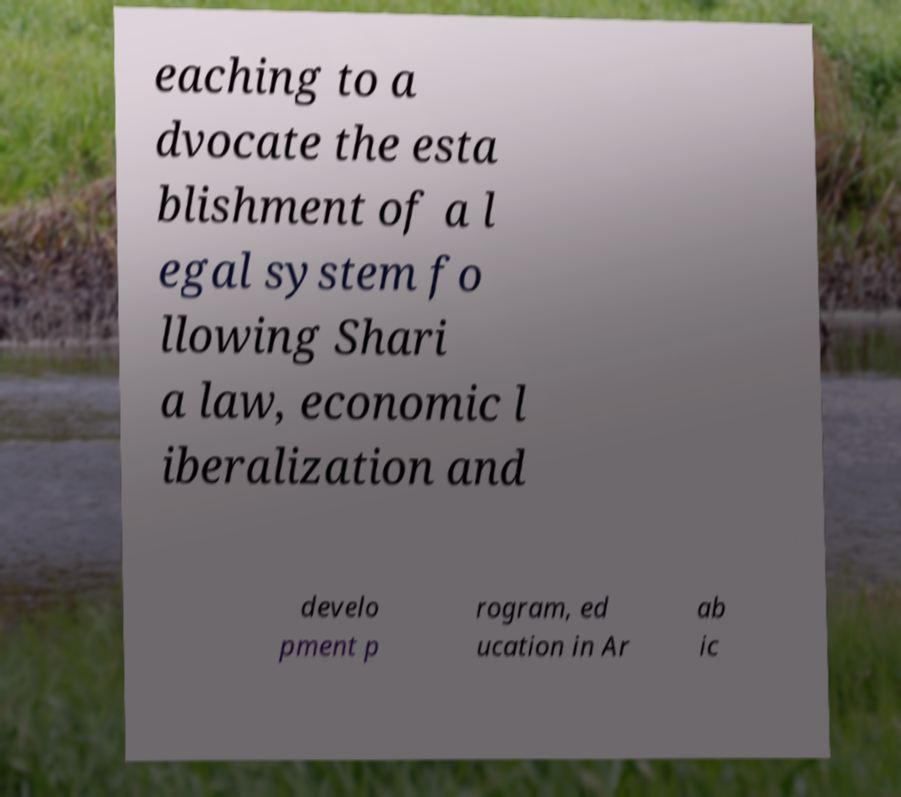Could you extract and type out the text from this image? eaching to a dvocate the esta blishment of a l egal system fo llowing Shari a law, economic l iberalization and develo pment p rogram, ed ucation in Ar ab ic 